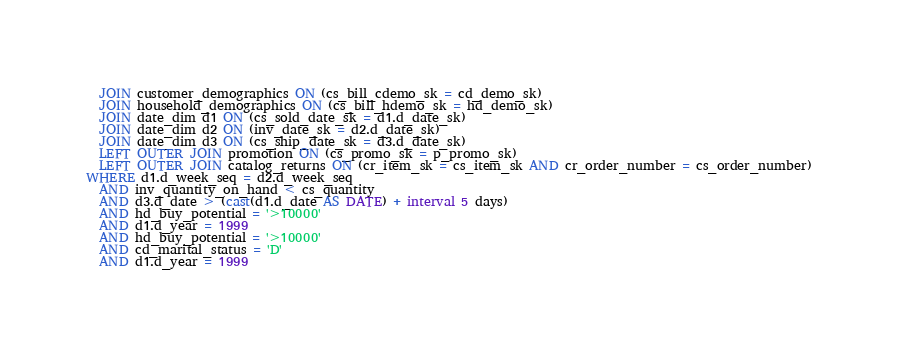<code> <loc_0><loc_0><loc_500><loc_500><_SQL_>  JOIN customer_demographics ON (cs_bill_cdemo_sk = cd_demo_sk)
  JOIN household_demographics ON (cs_bill_hdemo_sk = hd_demo_sk)
  JOIN date_dim d1 ON (cs_sold_date_sk = d1.d_date_sk)
  JOIN date_dim d2 ON (inv_date_sk = d2.d_date_sk)
  JOIN date_dim d3 ON (cs_ship_date_sk = d3.d_date_sk)
  LEFT OUTER JOIN promotion ON (cs_promo_sk = p_promo_sk)
  LEFT OUTER JOIN catalog_returns ON (cr_item_sk = cs_item_sk AND cr_order_number = cs_order_number)
WHERE d1.d_week_seq = d2.d_week_seq
  AND inv_quantity_on_hand < cs_quantity
  AND d3.d_date > (cast(d1.d_date AS DATE) + interval 5 days)
  AND hd_buy_potential = '>10000'
  AND d1.d_year = 1999
  AND hd_buy_potential = '>10000'
  AND cd_marital_status = 'D'
  AND d1.d_year = 1999</code> 